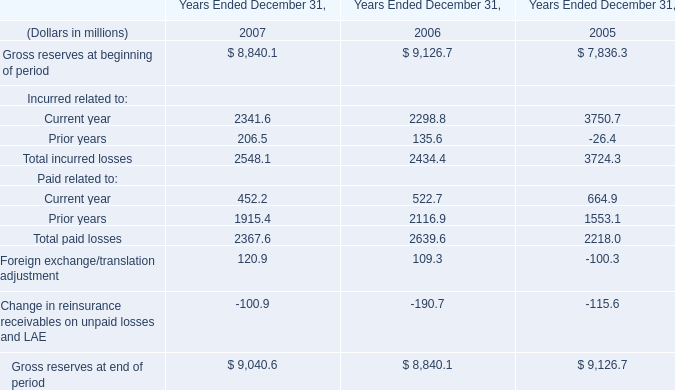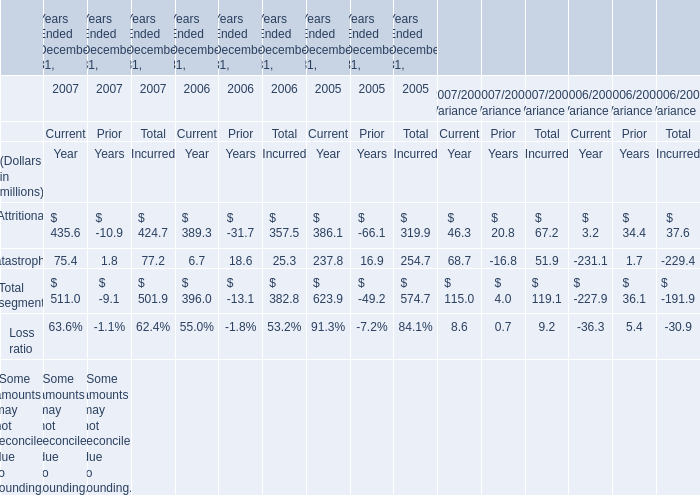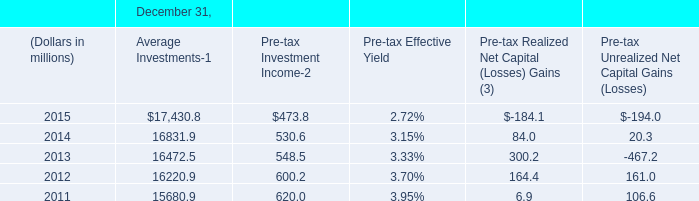What is the proportion of Attritional for Total Incurred to the total in 2007? 
Computations: (424.7 / 501.9)
Answer: 0.84618. 